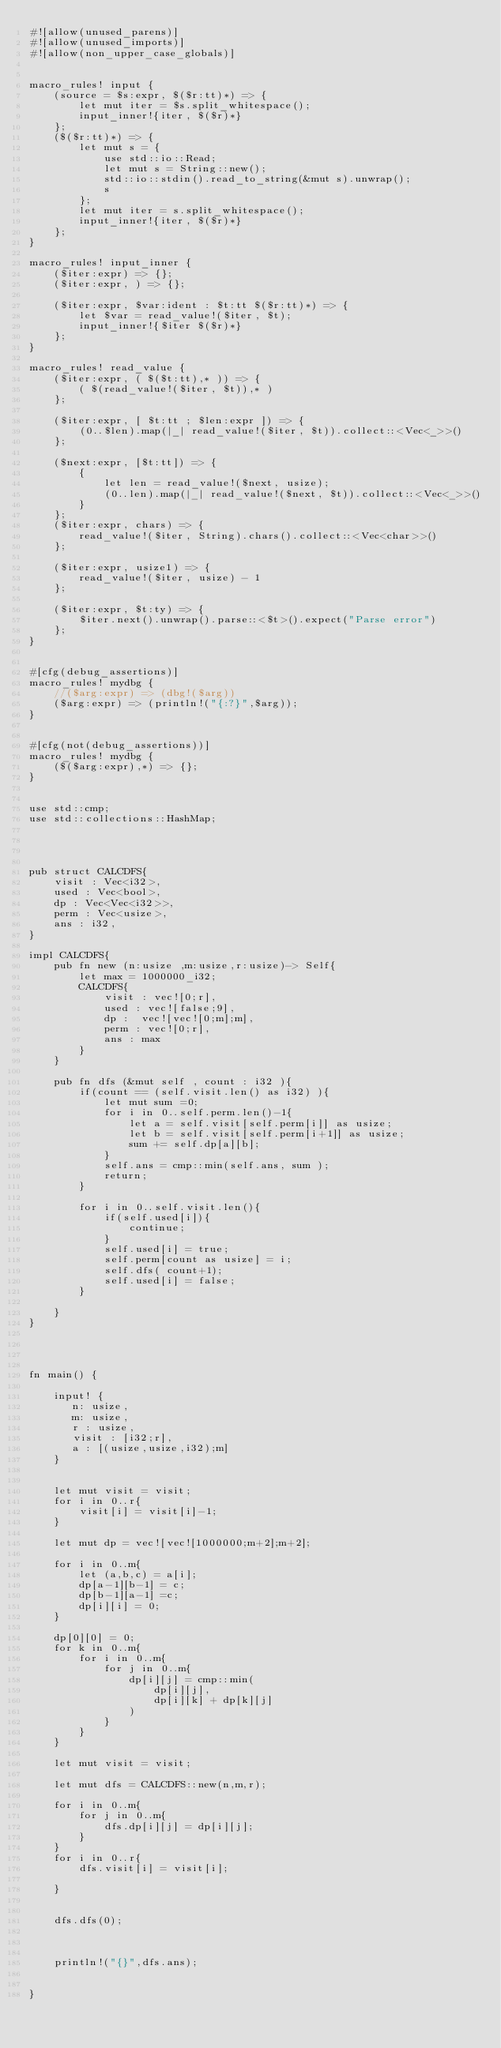Convert code to text. <code><loc_0><loc_0><loc_500><loc_500><_Rust_>#![allow(unused_parens)]
#![allow(unused_imports)]
#![allow(non_upper_case_globals)]


macro_rules! input {
    (source = $s:expr, $($r:tt)*) => {
        let mut iter = $s.split_whitespace();
        input_inner!{iter, $($r)*}
    };
    ($($r:tt)*) => {
        let mut s = {
            use std::io::Read;
            let mut s = String::new();
            std::io::stdin().read_to_string(&mut s).unwrap();
            s
        };
        let mut iter = s.split_whitespace();
        input_inner!{iter, $($r)*}
    };
}

macro_rules! input_inner {
    ($iter:expr) => {};
    ($iter:expr, ) => {};

    ($iter:expr, $var:ident : $t:tt $($r:tt)*) => {
        let $var = read_value!($iter, $t);
        input_inner!{$iter $($r)*}
    };
}

macro_rules! read_value {
    ($iter:expr, ( $($t:tt),* )) => {
        ( $(read_value!($iter, $t)),* )
    };

    ($iter:expr, [ $t:tt ; $len:expr ]) => {
        (0..$len).map(|_| read_value!($iter, $t)).collect::<Vec<_>>()
    };

    ($next:expr, [$t:tt]) => {
        {
            let len = read_value!($next, usize);
            (0..len).map(|_| read_value!($next, $t)).collect::<Vec<_>>()
        }
    };
    ($iter:expr, chars) => {
        read_value!($iter, String).chars().collect::<Vec<char>>()
    };

    ($iter:expr, usize1) => {
        read_value!($iter, usize) - 1
    };

    ($iter:expr, $t:ty) => {
        $iter.next().unwrap().parse::<$t>().expect("Parse error")
    };
}


#[cfg(debug_assertions)]
macro_rules! mydbg {
    //($arg:expr) => (dbg!($arg))
    ($arg:expr) => (println!("{:?}",$arg));
}


#[cfg(not(debug_assertions))]
macro_rules! mydbg {
    ($($arg:expr),*) => {};
}


use std::cmp;
use std::collections::HashMap;




pub struct CALCDFS{
    visit : Vec<i32>,
    used : Vec<bool>,
    dp : Vec<Vec<i32>>,
    perm : Vec<usize>,
    ans : i32,
}

impl CALCDFS{
    pub fn new (n:usize ,m:usize,r:usize)-> Self{
        let max = 1000000_i32;
        CALCDFS{
            visit : vec![0;r],
            used : vec![false;9],
            dp :  vec![vec![0;m];m],
            perm : vec![0;r],
            ans : max
        }
    }

    pub fn dfs (&mut self , count : i32 ){
        if(count == (self.visit.len() as i32) ){
            let mut sum =0;
            for i in 0..self.perm.len()-1{
                let a = self.visit[self.perm[i]] as usize;
                let b = self.visit[self.perm[i+1]] as usize;
                sum += self.dp[a][b];
            }
            self.ans = cmp::min(self.ans, sum );
            return;
        }
       
        for i in 0..self.visit.len(){
            if(self.used[i]){
                continue;
            }
            self.used[i] = true;
            self.perm[count as usize] = i;
            self.dfs( count+1);
            self.used[i] = false;
        }

    }
}




fn main() {

    input! { 
       n: usize,
       m: usize,
       r : usize,
       visit : [i32;r],
       a : [(usize,usize,i32);m]
    }


    let mut visit = visit;
    for i in 0..r{
        visit[i] = visit[i]-1;
    }

    let mut dp = vec![vec![1000000;m+2];m+2];

    for i in 0..m{
        let (a,b,c) = a[i];
        dp[a-1][b-1] = c;
        dp[b-1][a-1] =c;
        dp[i][i] = 0;
    }

    dp[0][0] = 0;
    for k in 0..m{
        for i in 0..m{
            for j in 0..m{
                dp[i][j] = cmp::min(
                    dp[i][j],
                    dp[i][k] + dp[k][j]                    
                )
            }
        }
    }

    let mut visit = visit;
    
    let mut dfs = CALCDFS::new(n,m,r);

    for i in 0..m{
        for j in 0..m{
            dfs.dp[i][j] = dp[i][j];
        }
    }
    for i in 0..r{
        dfs.visit[i] = visit[i];

    }

    
    dfs.dfs(0);


    
    println!("{}",dfs.ans);


}
</code> 